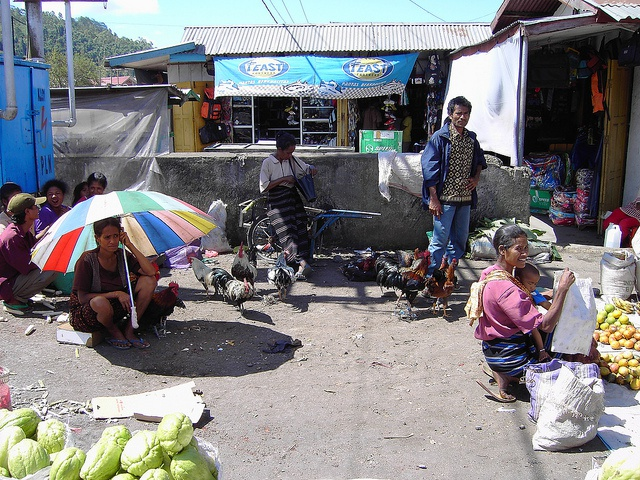Describe the objects in this image and their specific colors. I can see people in gray, black, maroon, and lightpink tones, umbrella in gray, white, lightblue, lightpink, and red tones, people in gray, black, maroon, and brown tones, people in gray, black, and navy tones, and people in gray and black tones in this image. 